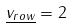Convert formula to latex. <formula><loc_0><loc_0><loc_500><loc_500>\underline { v _ { r o w } } = 2</formula> 